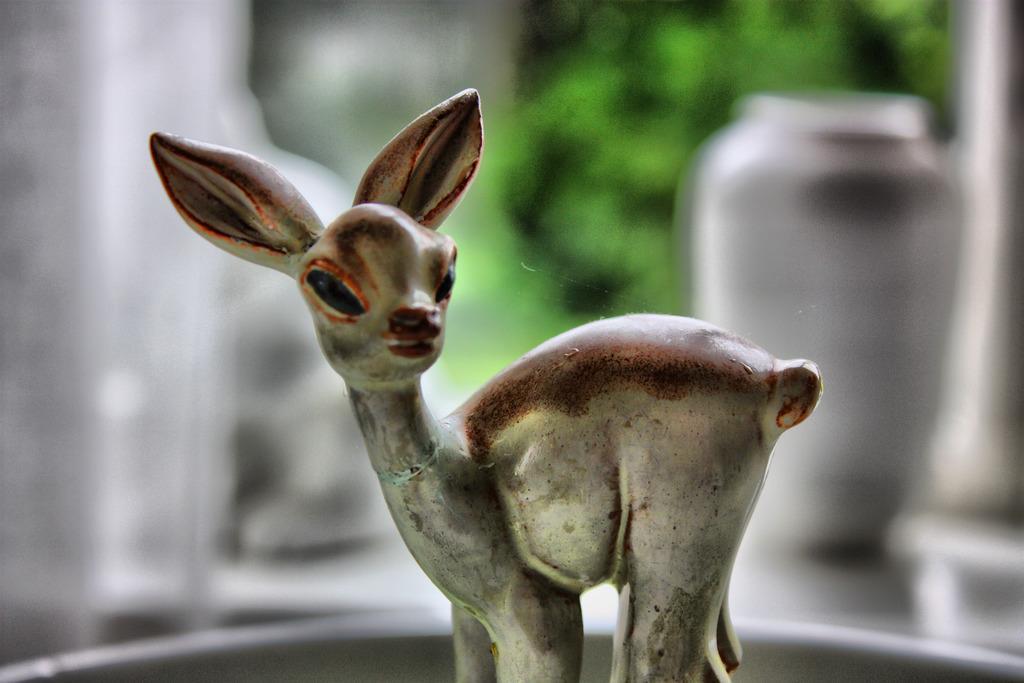Describe this image in one or two sentences. In this image I can see a toy which is in the shape of an animal which is cream, brown and black in color. I can see the blurry background in which I can see a ceramic vase and few trees which are green in color. 